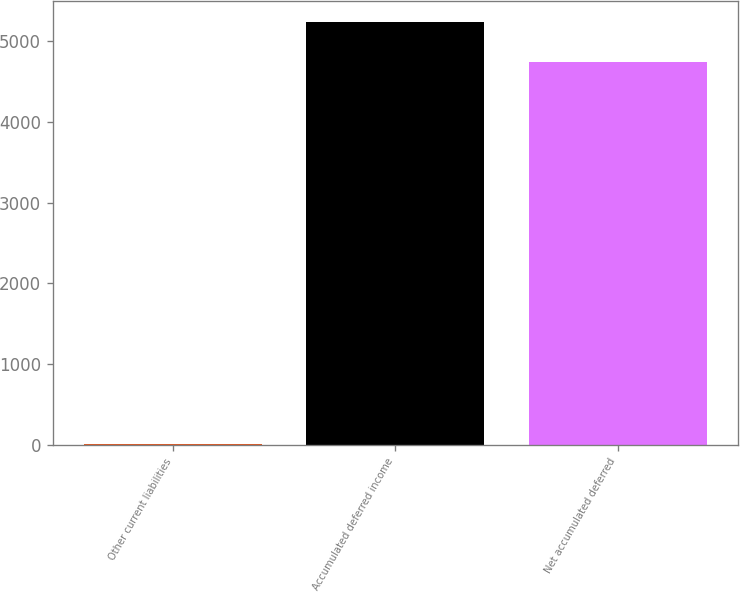Convert chart to OTSL. <chart><loc_0><loc_0><loc_500><loc_500><bar_chart><fcel>Other current liabilities<fcel>Accumulated deferred income<fcel>Net accumulated deferred<nl><fcel>14<fcel>5230.6<fcel>4746<nl></chart> 